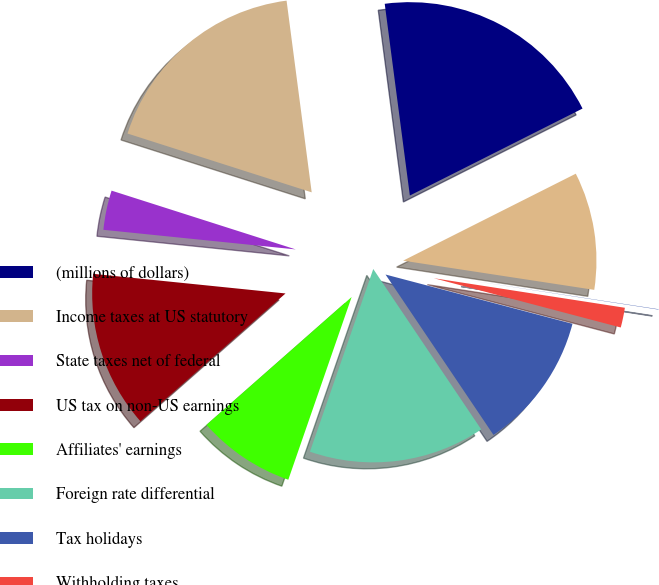<chart> <loc_0><loc_0><loc_500><loc_500><pie_chart><fcel>(millions of dollars)<fcel>Income taxes at US statutory<fcel>State taxes net of federal<fcel>US tax on non-US earnings<fcel>Affiliates' earnings<fcel>Foreign rate differential<fcel>Tax holidays<fcel>Withholding taxes<fcel>Tax credits<fcel>Reserve adjustments<nl><fcel>19.65%<fcel>18.01%<fcel>3.3%<fcel>13.11%<fcel>8.2%<fcel>14.74%<fcel>11.47%<fcel>1.66%<fcel>0.03%<fcel>9.84%<nl></chart> 